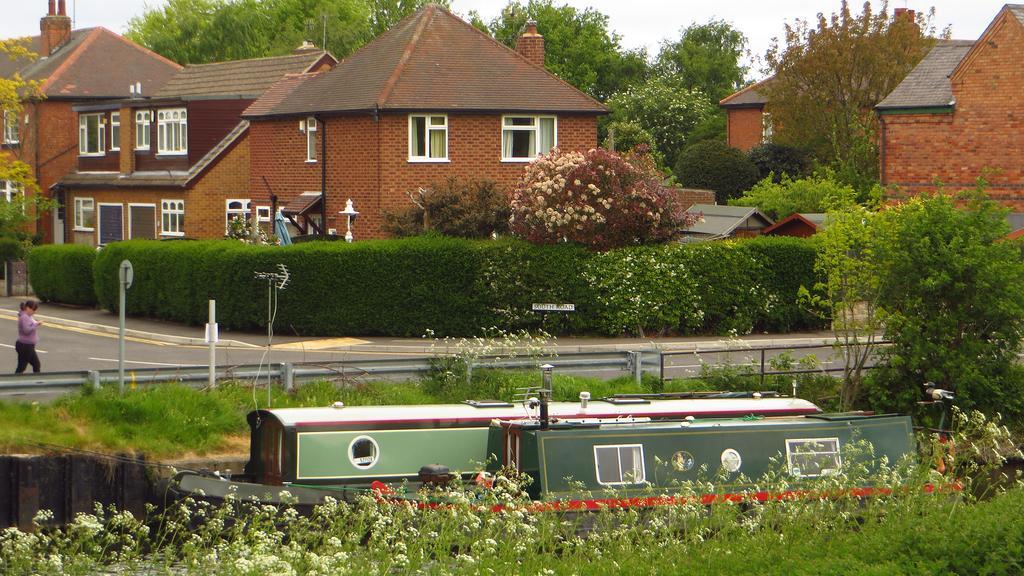Could you give a brief overview of what you see in this image? There are plants having flowers and there are boats. In the background, there are boats, there are trees, plants and grass on the ground near a fencing, there is a person walking on the road, there are plants, trees, buildings which are having windows and roofs and there is sky. 